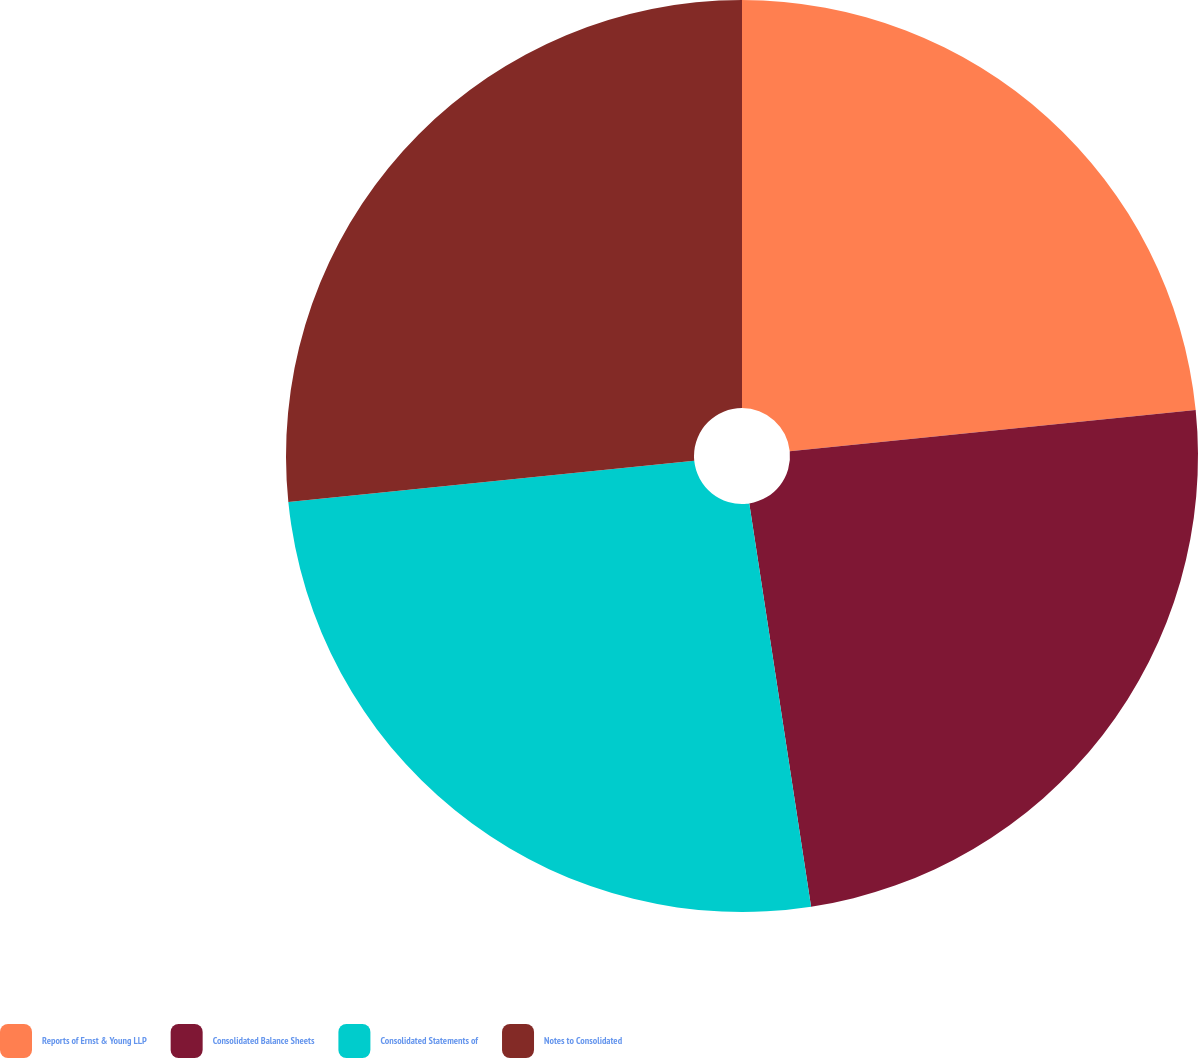Convert chart. <chart><loc_0><loc_0><loc_500><loc_500><pie_chart><fcel>Reports of Ernst & Young LLP<fcel>Consolidated Balance Sheets<fcel>Consolidated Statements of<fcel>Notes to Consolidated<nl><fcel>23.39%<fcel>24.19%<fcel>25.81%<fcel>26.61%<nl></chart> 